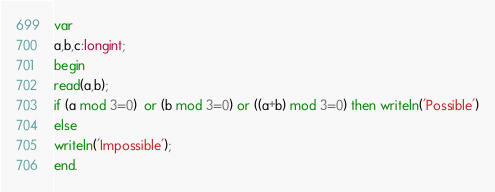Convert code to text. <code><loc_0><loc_0><loc_500><loc_500><_Pascal_>var
a,b,c:longint;
begin
read(a,b);
if (a mod 3=0)  or (b mod 3=0) or ((a+b) mod 3=0) then writeln('Possible')
else
writeln('Impossible');
end.</code> 